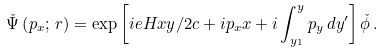<formula> <loc_0><loc_0><loc_500><loc_500>\check { \Psi } \left ( p _ { x } ; \, { r } \right ) = \exp \left [ i e H x y / 2 c + i p _ { x } x + i \int _ { y _ { 1 } } ^ { y } p _ { y } \, d y ^ { \prime } \right ] \check { \phi } \, .</formula> 